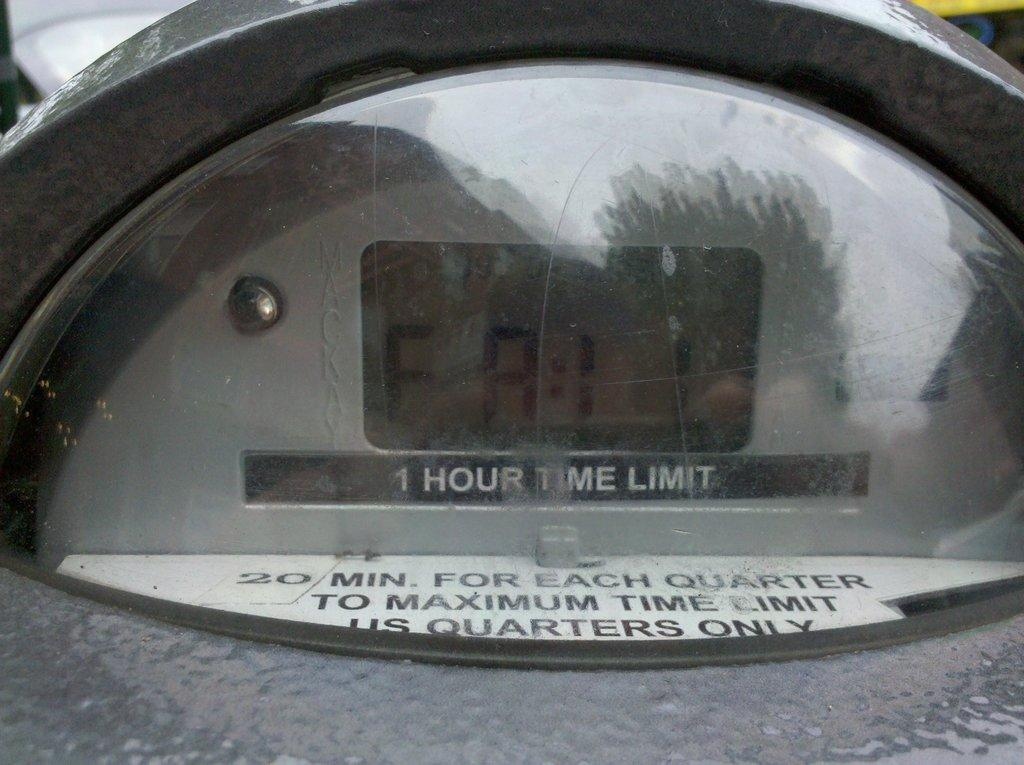<image>
Write a terse but informative summary of the picture. A closeup on a parking meter shows that it has a one hour time limit. 